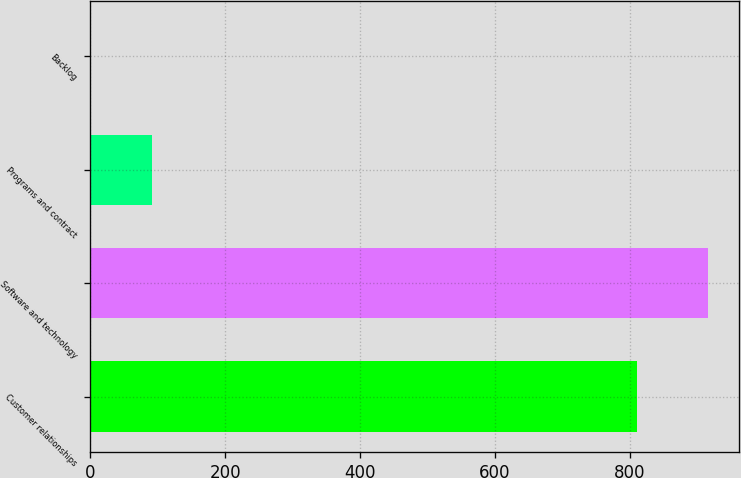Convert chart. <chart><loc_0><loc_0><loc_500><loc_500><bar_chart><fcel>Customer relationships<fcel>Software and technology<fcel>Programs and contract<fcel>Backlog<nl><fcel>810<fcel>915<fcel>92.4<fcel>1<nl></chart> 